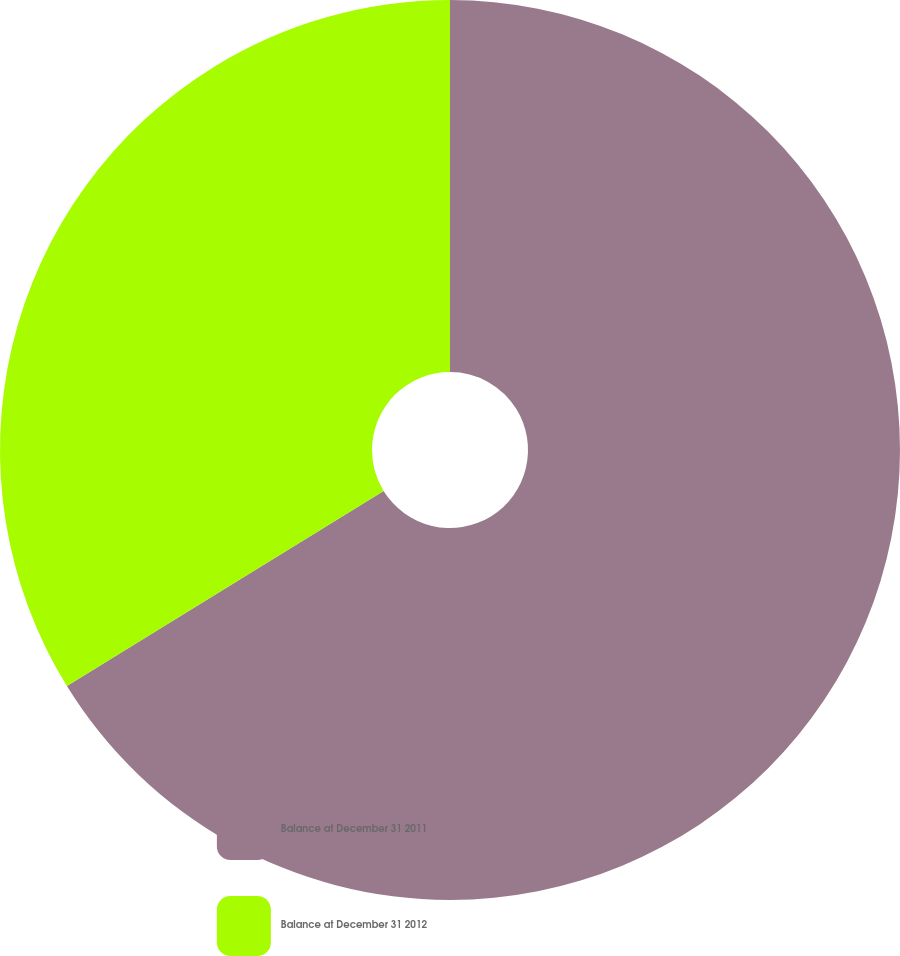Convert chart. <chart><loc_0><loc_0><loc_500><loc_500><pie_chart><fcel>Balance at December 31 2011<fcel>Balance at December 31 2012<nl><fcel>66.21%<fcel>33.79%<nl></chart> 